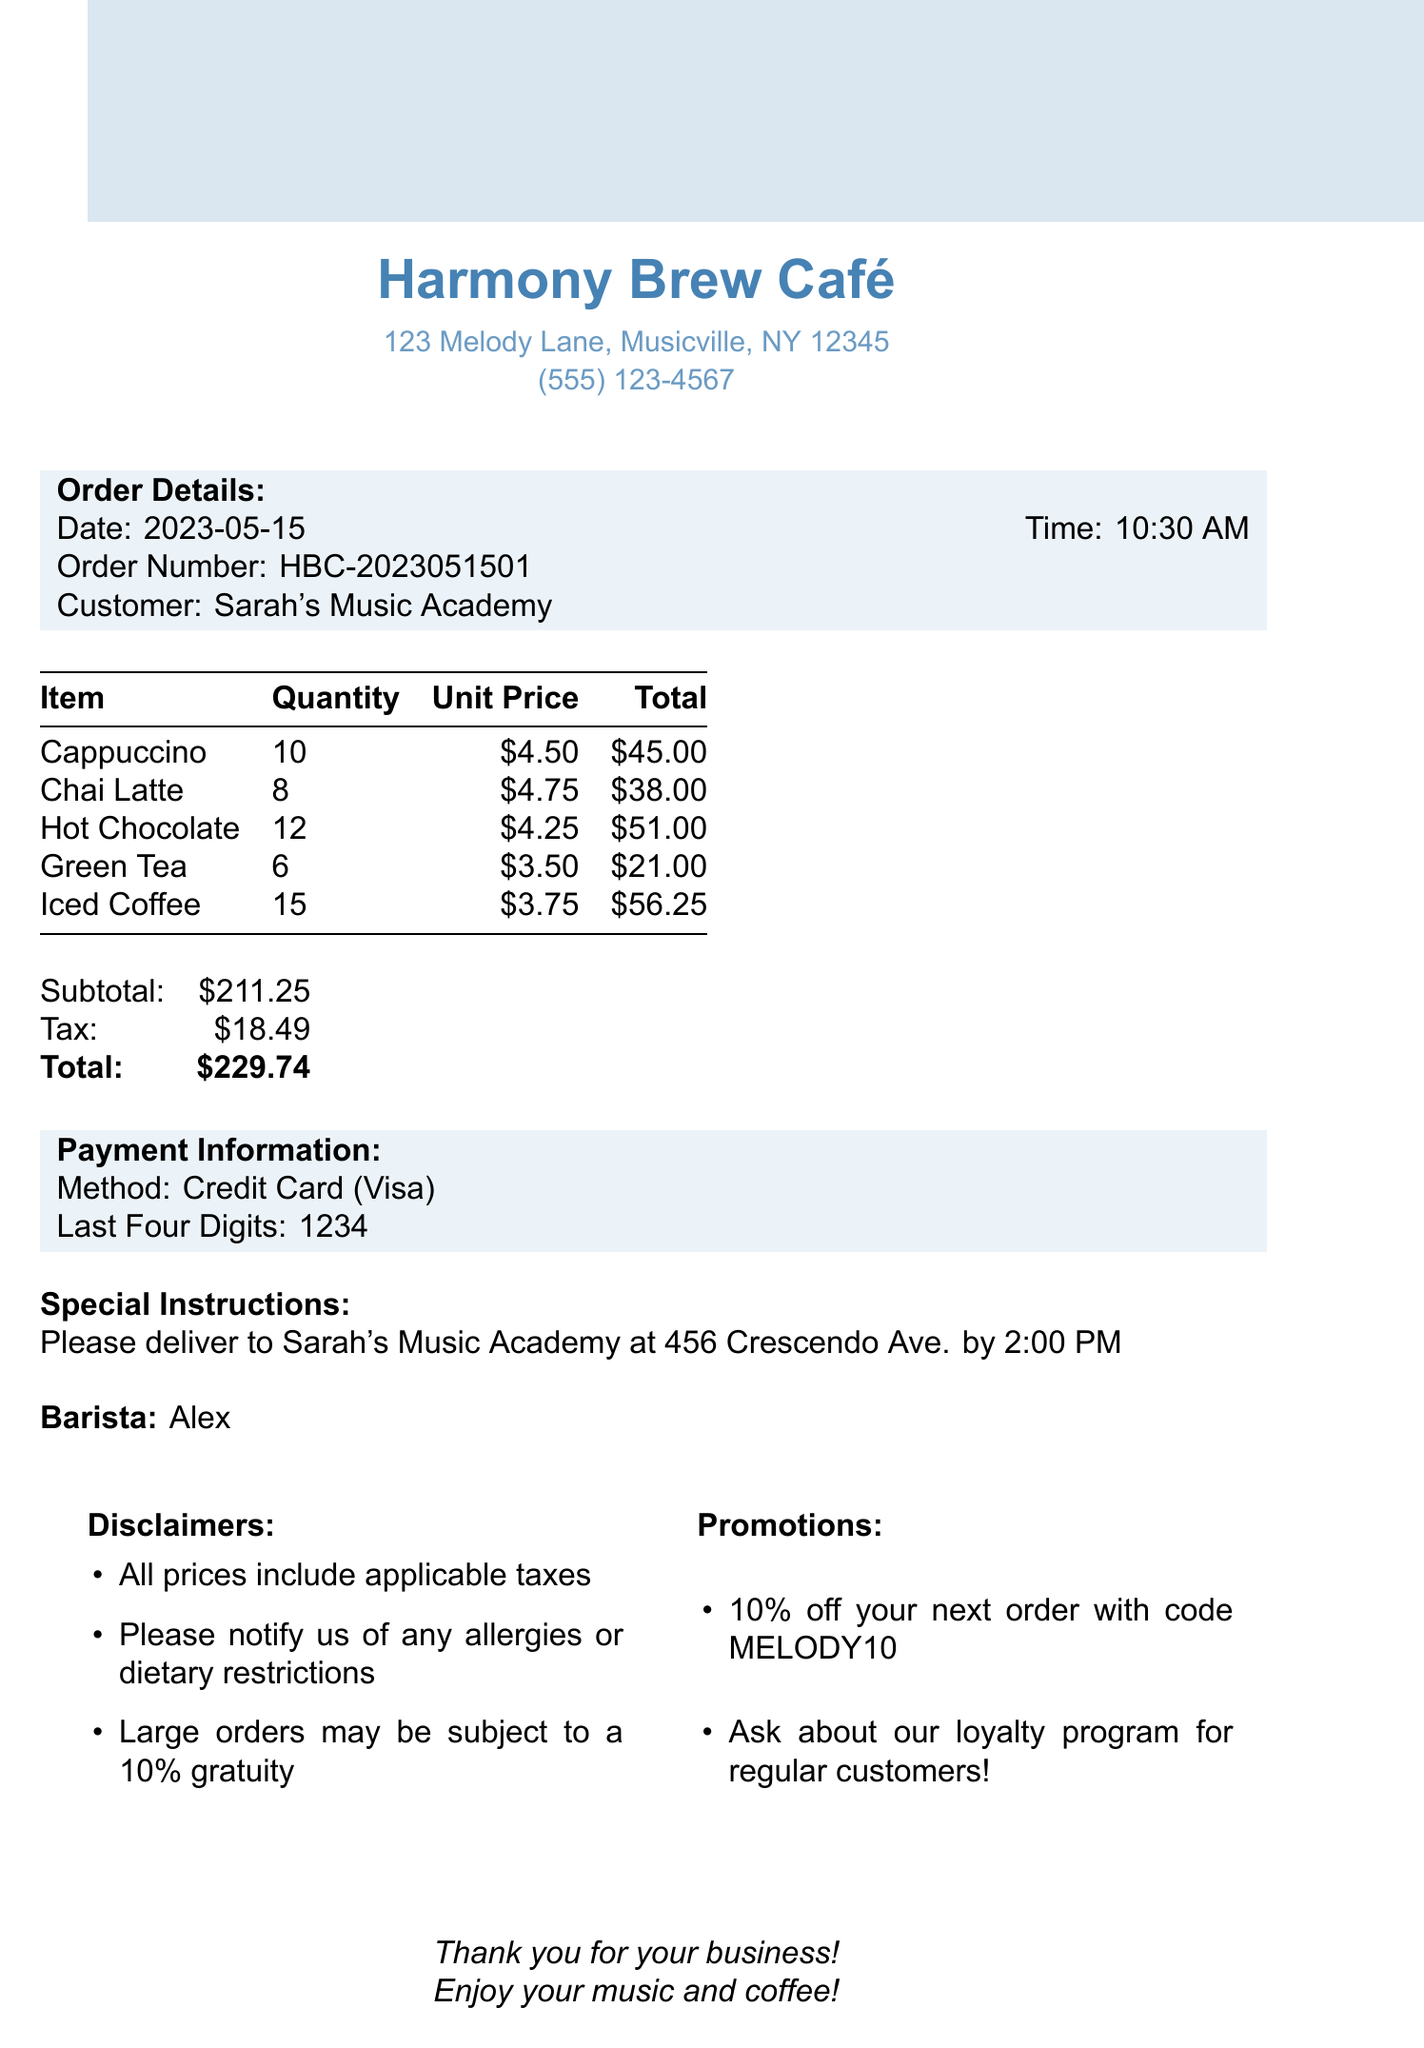What is the order date? The order date is clearly indicated in the document as "2023-05-15".
Answer: 2023-05-15 What is the total amount due? The total amount due is specified in the document under "Total," which sums the subtotal and tax.
Answer: $229.74 Who is the barista that prepared the order? The name of the barista is mentioned in the document, which is relevant for customer engagement or feedback.
Answer: Alex How many Iced Coffees were ordered? The quantity of Iced Coffees is detailed in the itemized list in the document.
Answer: 15 What is the subtotal before tax? The subtotal figure is explicitly stated in the document, which is necessary for understanding the total cost breakdown.
Answer: $211.25 What is the delivery address? The delivery instructions in the document specify the address where the order should be delivered.
Answer: 456 Crescendo Ave What is the promotional code provided? The document lists a promotional code available for the next order as part of customer incentives.
Answer: MELODY10 How many different types of beverages are included in the order? The document outlines multiple itemized beverages, requiring counting for total variety.
Answer: 5 Is there a gratuity for large orders? The disclaimers section in the document mentions a potential gratuity for large orders, which is relevant for budgeting.
Answer: 10% 